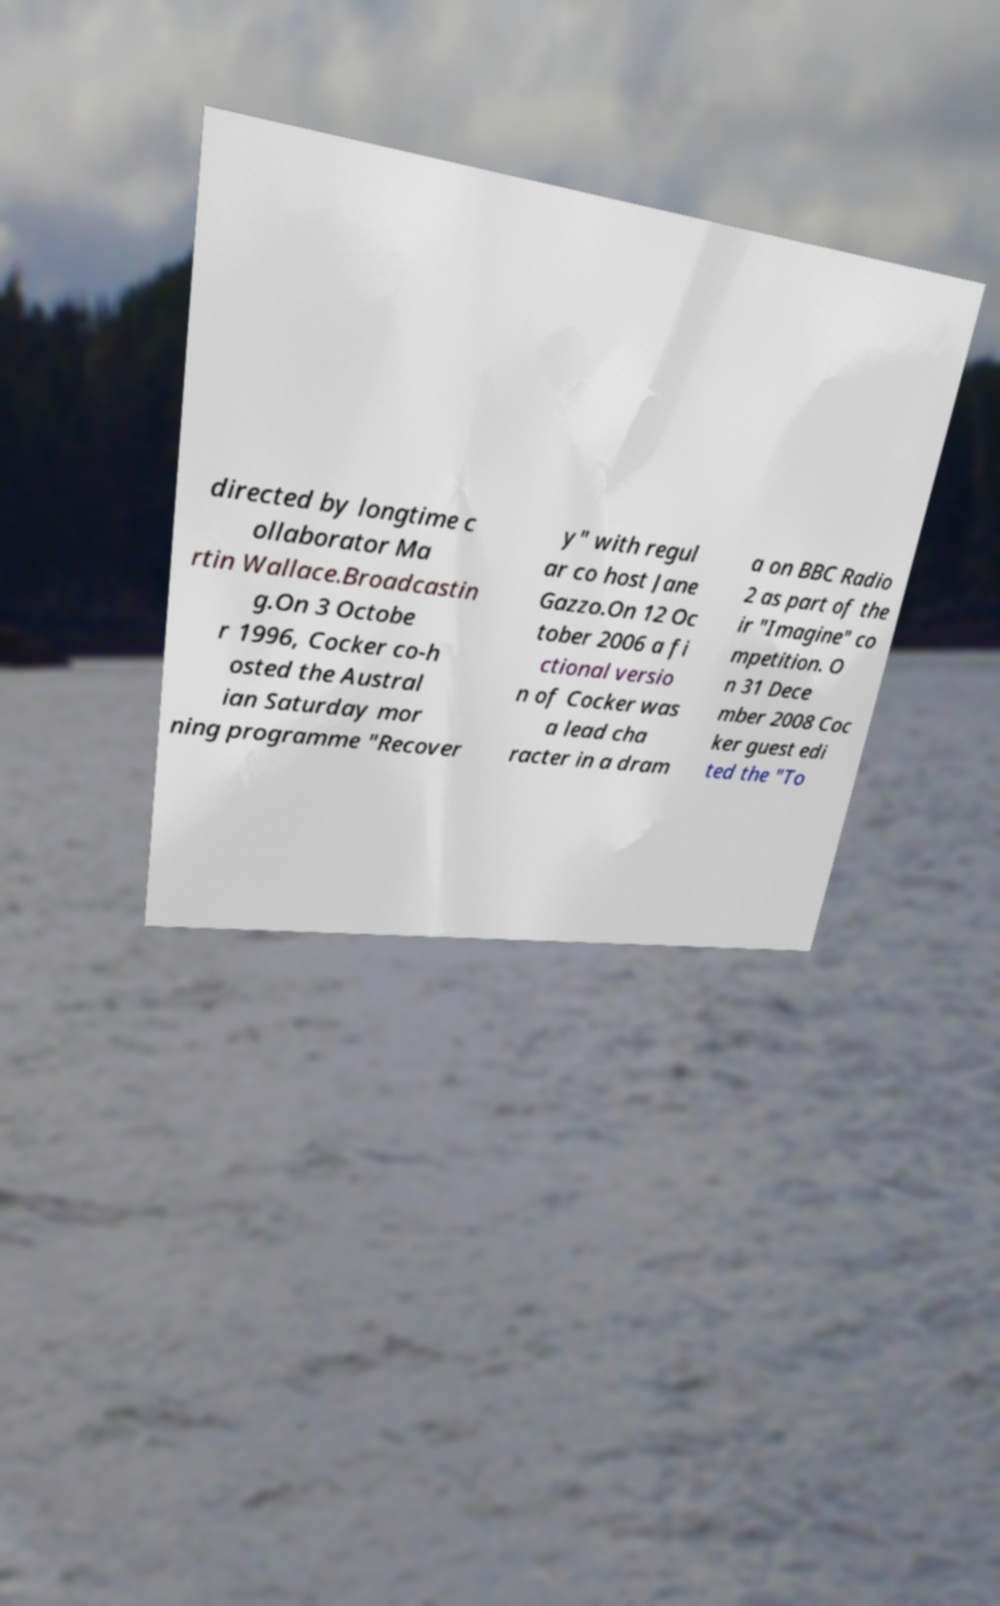Please read and relay the text visible in this image. What does it say? directed by longtime c ollaborator Ma rtin Wallace.Broadcastin g.On 3 Octobe r 1996, Cocker co-h osted the Austral ian Saturday mor ning programme "Recover y" with regul ar co host Jane Gazzo.On 12 Oc tober 2006 a fi ctional versio n of Cocker was a lead cha racter in a dram a on BBC Radio 2 as part of the ir "Imagine" co mpetition. O n 31 Dece mber 2008 Coc ker guest edi ted the "To 